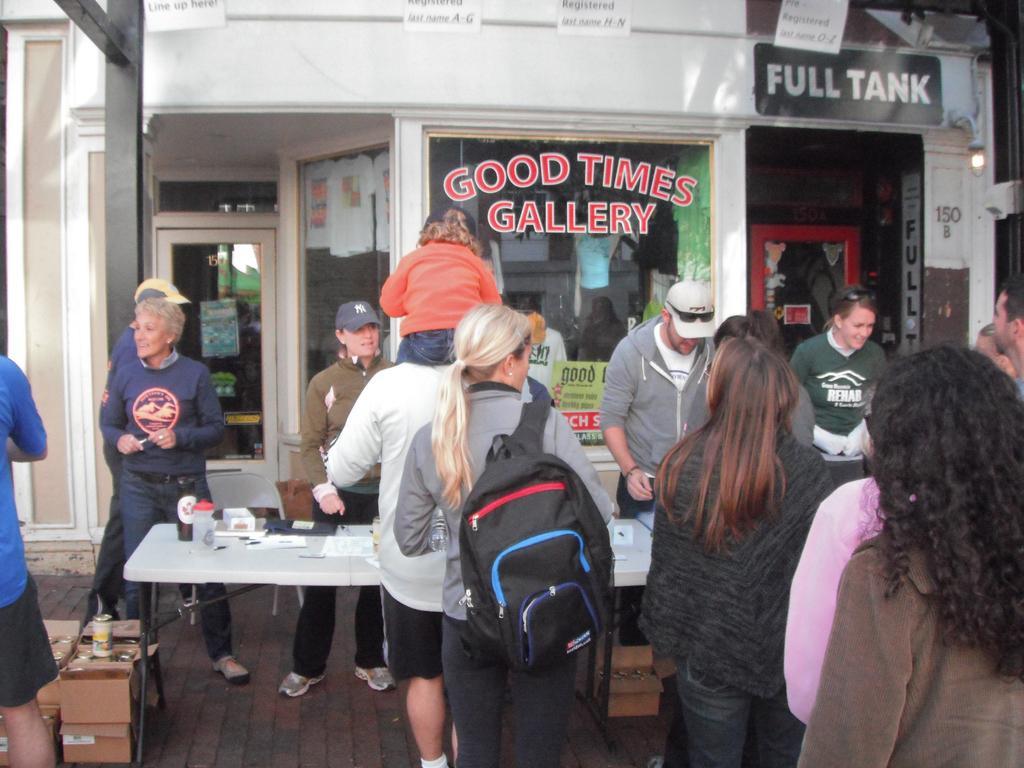Could you give a brief overview of what you see in this image? In this image there are group of people. The woman is wearing a bag. At the back side there is building. On the table there are papers. 